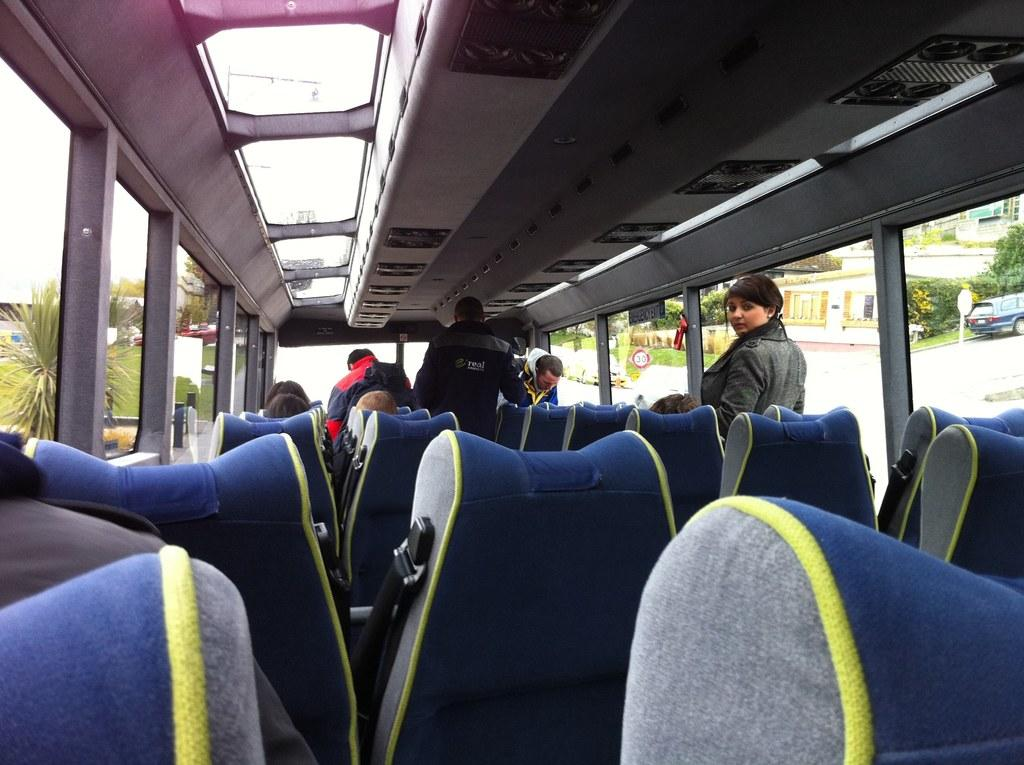Where was the image taken? The image was taken inside a vehicle. What can be found inside the vehicle? There are seats and people inside the vehicle. What features does the vehicle have? The vehicle has windows and lights. What can be seen through the windows? Plants, buildings, vehicles, sign boards, and grass can be seen through the windows. What is the birth rate of the things visible through the windows? There is no birth rate mentioned or implied in the image, as it only shows various objects and scenery visible through the windows. --- Facts: 1. There is a person holding a book in the image. 2. The person is sitting on a chair. 3. The chair is made of wood. 4. The book has a blue cover. 5. The person is wearing glasses. 6. There is a table next to the chair. 7. The table has a lamp on it. Absurd Topics: elephant, ocean, dance Conversation: What is the person in the image holding? The person is holding a book in the image. What is the person sitting on? The person is sitting on a wooden chair. What color is the book's cover? The book has a blue cover. What accessory is the person wearing? The person is wearing glasses. What is located next to the chair? There is a table next to the chair. What is on the table? The table has a lamp on it. Reasoning: Let's think step by step in order to produce the conversation. We start by identifying the main subject in the image, which is the person holding a book. Then, we describe the person's position and the chair they are sitting on. Next, we mention the color of the book's cover and the accessory the person is wearing. Finally, we focus on the objects located next to the chair, including the table and the lamp on it. Absurd Question/Answer: Can you see an elephant swimming in the ocean in the image? No, there is no elephant or ocean present in the image. 